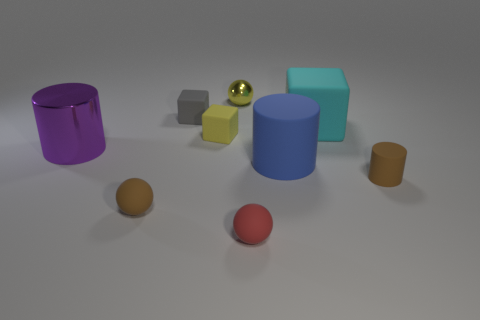What number of other things are made of the same material as the tiny yellow block?
Make the answer very short. 6. There is a large cylinder that is on the right side of the purple object; is there a blue cylinder right of it?
Your answer should be compact. No. Are there any other things that have the same shape as the big cyan rubber object?
Your answer should be compact. Yes. What is the color of the other large rubber object that is the same shape as the big purple thing?
Keep it short and to the point. Blue. What size is the yellow rubber cube?
Your answer should be very brief. Small. Are there fewer brown cylinders behind the metallic sphere than tiny metal spheres?
Provide a succinct answer. Yes. Is the tiny yellow block made of the same material as the cylinder that is to the left of the large blue thing?
Ensure brevity in your answer.  No. Is there a brown cylinder that is in front of the tiny thing right of the large rubber thing behind the blue matte cylinder?
Ensure brevity in your answer.  No. Is there anything else that has the same size as the gray matte thing?
Your answer should be very brief. Yes. The large cylinder that is the same material as the tiny cylinder is what color?
Provide a short and direct response. Blue. 